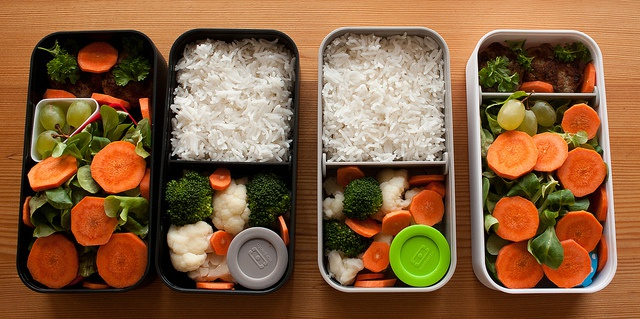Describe the objects in this image and their specific colors. I can see dining table in black, tan, maroon, lightgray, and brown tones, bowl in red, black, olive, and lightgray tones, bowl in red, black, brown, and olive tones, bowl in red, lightgray, black, and darkgray tones, and bowl in red, black, lightgray, darkgray, and tan tones in this image. 